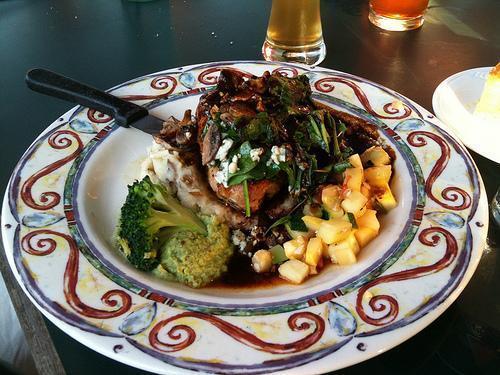How many utensils?
Give a very brief answer. 1. 